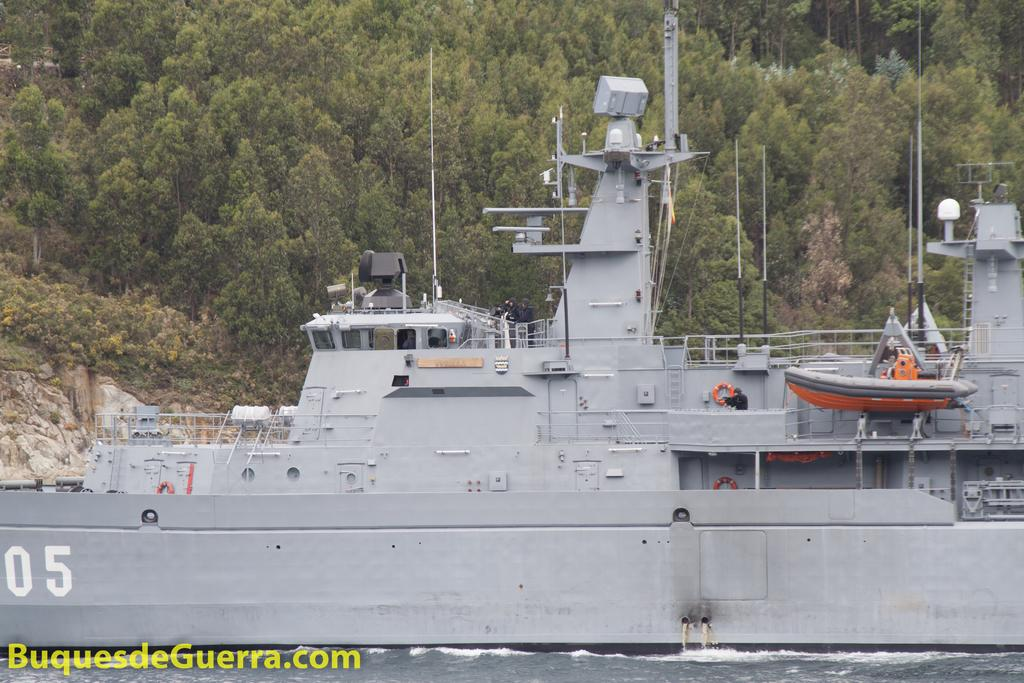What is the main subject of the image? There is a ship in the image. Where is the ship located in relation to the water? The ship is on the surface of the water. What can be seen in the background of the image? There are trees visible in the background of the image. Is there any text present in the image? Yes, there is text in the bottom left corner of the image. What type of straw is being used to cast a wave in the image? There is no straw or casting of a wave present in the image. 